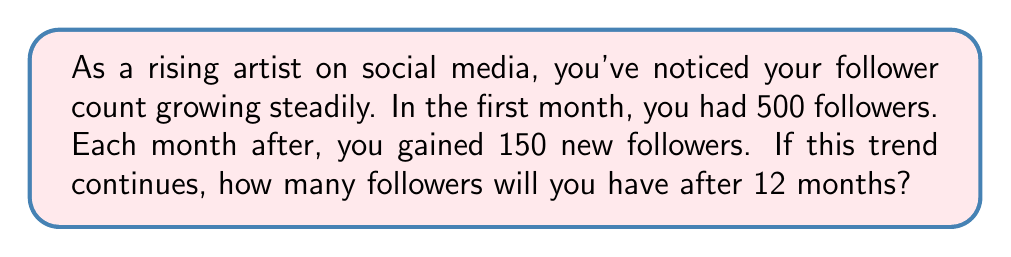Show me your answer to this math problem. Let's approach this step-by-step using arithmetic progression:

1) First, identify the components of the arithmetic sequence:
   - $a_1 = 500$ (initial term, followers in the first month)
   - $d = 150$ (common difference, followers gained each month)
   - $n = 12$ (number of terms, months)

2) The formula for the nth term of an arithmetic sequence is:
   $a_n = a_1 + (n - 1)d$

3) We want to find $a_{12}$, so let's substitute the values:
   $a_{12} = 500 + (12 - 1)150$

4) Simplify:
   $a_{12} = 500 + (11)150$
   $a_{12} = 500 + 1650$
   $a_{12} = 2150$

5) Therefore, after 12 months, you will have 2150 followers.

However, the question asks for the total number of followers, which is the sum of all terms up to the 12th month. We can use the arithmetic series formula:

6) The formula for the sum of an arithmetic series is:
   $S_n = \frac{n}{2}(a_1 + a_n)$

7) We know $n = 12$, $a_1 = 500$, and $a_{12} = 2150$. Let's substitute:
   $S_{12} = \frac{12}{2}(500 + 2150)$

8) Simplify:
   $S_{12} = 6(2650)$
   $S_{12} = 15900$

Thus, after 12 months, you will have a total of 15,900 followers.
Answer: 15,900 followers 